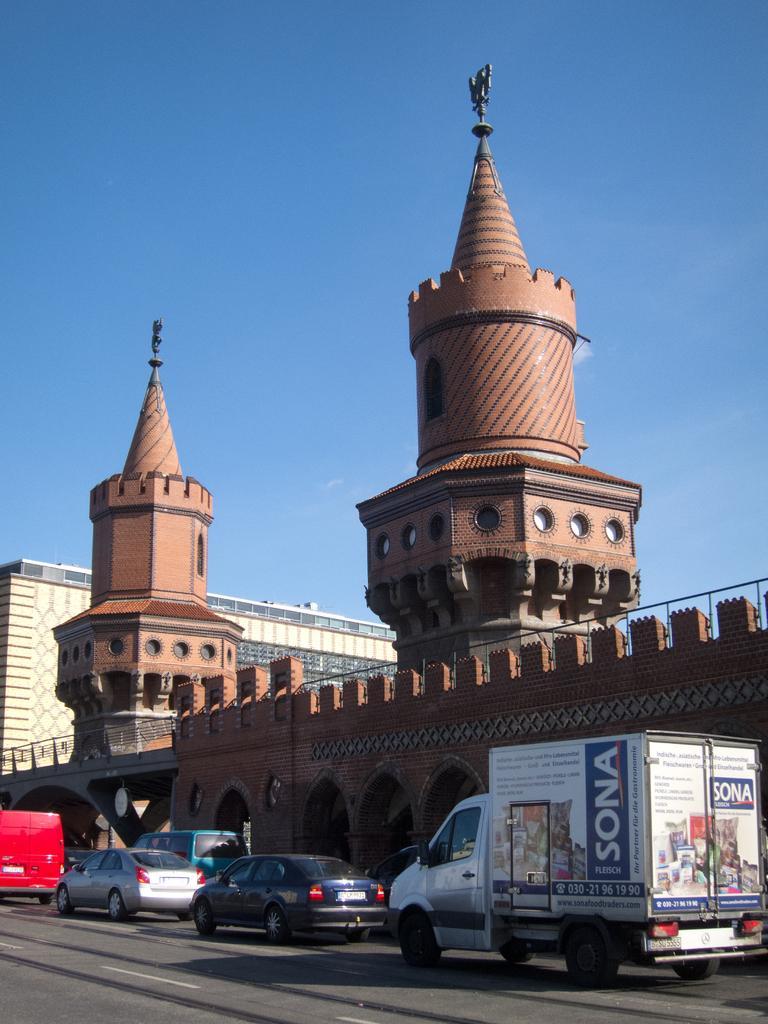Please provide a concise description of this image. We can see vehicles on the road. In the background we can see buildings and sky in blue color. 